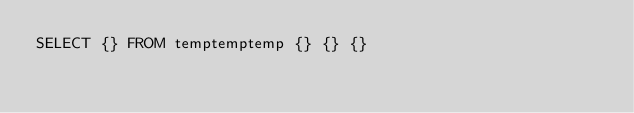<code> <loc_0><loc_0><loc_500><loc_500><_SQL_>SELECT {} FROM temptemptemp {} {} {}
</code> 